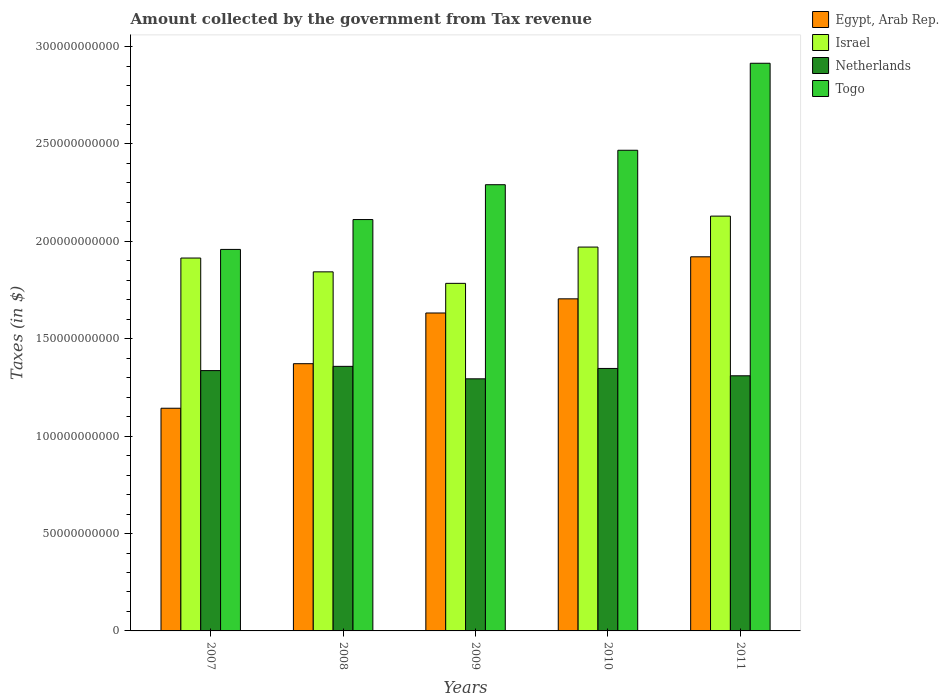How many different coloured bars are there?
Offer a terse response. 4. How many groups of bars are there?
Your answer should be compact. 5. Are the number of bars per tick equal to the number of legend labels?
Your answer should be compact. Yes. Are the number of bars on each tick of the X-axis equal?
Your answer should be very brief. Yes. What is the label of the 5th group of bars from the left?
Keep it short and to the point. 2011. In how many cases, is the number of bars for a given year not equal to the number of legend labels?
Your answer should be very brief. 0. What is the amount collected by the government from tax revenue in Israel in 2007?
Make the answer very short. 1.91e+11. Across all years, what is the maximum amount collected by the government from tax revenue in Israel?
Give a very brief answer. 2.13e+11. Across all years, what is the minimum amount collected by the government from tax revenue in Netherlands?
Offer a terse response. 1.29e+11. In which year was the amount collected by the government from tax revenue in Egypt, Arab Rep. maximum?
Your response must be concise. 2011. What is the total amount collected by the government from tax revenue in Israel in the graph?
Keep it short and to the point. 9.64e+11. What is the difference between the amount collected by the government from tax revenue in Netherlands in 2007 and that in 2009?
Keep it short and to the point. 4.22e+09. What is the difference between the amount collected by the government from tax revenue in Egypt, Arab Rep. in 2008 and the amount collected by the government from tax revenue in Netherlands in 2010?
Offer a terse response. 2.44e+09. What is the average amount collected by the government from tax revenue in Netherlands per year?
Provide a succinct answer. 1.33e+11. In the year 2007, what is the difference between the amount collected by the government from tax revenue in Egypt, Arab Rep. and amount collected by the government from tax revenue in Togo?
Your answer should be very brief. -8.15e+1. What is the ratio of the amount collected by the government from tax revenue in Netherlands in 2008 to that in 2010?
Provide a succinct answer. 1.01. Is the amount collected by the government from tax revenue in Netherlands in 2007 less than that in 2010?
Offer a very short reply. Yes. What is the difference between the highest and the second highest amount collected by the government from tax revenue in Egypt, Arab Rep.?
Your answer should be very brief. 2.16e+1. What is the difference between the highest and the lowest amount collected by the government from tax revenue in Netherlands?
Your response must be concise. 6.40e+09. In how many years, is the amount collected by the government from tax revenue in Israel greater than the average amount collected by the government from tax revenue in Israel taken over all years?
Make the answer very short. 2. Is the sum of the amount collected by the government from tax revenue in Togo in 2007 and 2010 greater than the maximum amount collected by the government from tax revenue in Netherlands across all years?
Ensure brevity in your answer.  Yes. What does the 3rd bar from the left in 2008 represents?
Make the answer very short. Netherlands. What does the 2nd bar from the right in 2009 represents?
Give a very brief answer. Netherlands. Is it the case that in every year, the sum of the amount collected by the government from tax revenue in Netherlands and amount collected by the government from tax revenue in Togo is greater than the amount collected by the government from tax revenue in Israel?
Offer a terse response. Yes. Are the values on the major ticks of Y-axis written in scientific E-notation?
Provide a succinct answer. No. Does the graph contain any zero values?
Provide a short and direct response. No. Does the graph contain grids?
Offer a terse response. No. How many legend labels are there?
Give a very brief answer. 4. How are the legend labels stacked?
Offer a very short reply. Vertical. What is the title of the graph?
Ensure brevity in your answer.  Amount collected by the government from Tax revenue. Does "Andorra" appear as one of the legend labels in the graph?
Your answer should be very brief. No. What is the label or title of the X-axis?
Give a very brief answer. Years. What is the label or title of the Y-axis?
Provide a succinct answer. Taxes (in $). What is the Taxes (in $) in Egypt, Arab Rep. in 2007?
Your answer should be very brief. 1.14e+11. What is the Taxes (in $) of Israel in 2007?
Your response must be concise. 1.91e+11. What is the Taxes (in $) in Netherlands in 2007?
Offer a very short reply. 1.34e+11. What is the Taxes (in $) of Togo in 2007?
Ensure brevity in your answer.  1.96e+11. What is the Taxes (in $) of Egypt, Arab Rep. in 2008?
Make the answer very short. 1.37e+11. What is the Taxes (in $) of Israel in 2008?
Make the answer very short. 1.84e+11. What is the Taxes (in $) of Netherlands in 2008?
Give a very brief answer. 1.36e+11. What is the Taxes (in $) of Togo in 2008?
Ensure brevity in your answer.  2.11e+11. What is the Taxes (in $) in Egypt, Arab Rep. in 2009?
Ensure brevity in your answer.  1.63e+11. What is the Taxes (in $) of Israel in 2009?
Offer a very short reply. 1.78e+11. What is the Taxes (in $) in Netherlands in 2009?
Make the answer very short. 1.29e+11. What is the Taxes (in $) in Togo in 2009?
Offer a very short reply. 2.29e+11. What is the Taxes (in $) of Egypt, Arab Rep. in 2010?
Your response must be concise. 1.70e+11. What is the Taxes (in $) in Israel in 2010?
Offer a terse response. 1.97e+11. What is the Taxes (in $) of Netherlands in 2010?
Offer a terse response. 1.35e+11. What is the Taxes (in $) in Togo in 2010?
Provide a succinct answer. 2.47e+11. What is the Taxes (in $) in Egypt, Arab Rep. in 2011?
Ensure brevity in your answer.  1.92e+11. What is the Taxes (in $) in Israel in 2011?
Offer a very short reply. 2.13e+11. What is the Taxes (in $) of Netherlands in 2011?
Ensure brevity in your answer.  1.31e+11. What is the Taxes (in $) in Togo in 2011?
Make the answer very short. 2.91e+11. Across all years, what is the maximum Taxes (in $) of Egypt, Arab Rep.?
Your answer should be very brief. 1.92e+11. Across all years, what is the maximum Taxes (in $) in Israel?
Provide a short and direct response. 2.13e+11. Across all years, what is the maximum Taxes (in $) in Netherlands?
Provide a short and direct response. 1.36e+11. Across all years, what is the maximum Taxes (in $) in Togo?
Keep it short and to the point. 2.91e+11. Across all years, what is the minimum Taxes (in $) in Egypt, Arab Rep.?
Ensure brevity in your answer.  1.14e+11. Across all years, what is the minimum Taxes (in $) of Israel?
Your answer should be compact. 1.78e+11. Across all years, what is the minimum Taxes (in $) of Netherlands?
Ensure brevity in your answer.  1.29e+11. Across all years, what is the minimum Taxes (in $) in Togo?
Your response must be concise. 1.96e+11. What is the total Taxes (in $) in Egypt, Arab Rep. in the graph?
Give a very brief answer. 7.77e+11. What is the total Taxes (in $) in Israel in the graph?
Keep it short and to the point. 9.64e+11. What is the total Taxes (in $) of Netherlands in the graph?
Ensure brevity in your answer.  6.65e+11. What is the total Taxes (in $) in Togo in the graph?
Provide a succinct answer. 1.17e+12. What is the difference between the Taxes (in $) of Egypt, Arab Rep. in 2007 and that in 2008?
Offer a very short reply. -2.29e+1. What is the difference between the Taxes (in $) of Israel in 2007 and that in 2008?
Offer a terse response. 7.09e+09. What is the difference between the Taxes (in $) of Netherlands in 2007 and that in 2008?
Offer a very short reply. -2.18e+09. What is the difference between the Taxes (in $) in Togo in 2007 and that in 2008?
Provide a short and direct response. -1.53e+1. What is the difference between the Taxes (in $) of Egypt, Arab Rep. in 2007 and that in 2009?
Ensure brevity in your answer.  -4.89e+1. What is the difference between the Taxes (in $) in Israel in 2007 and that in 2009?
Give a very brief answer. 1.30e+1. What is the difference between the Taxes (in $) of Netherlands in 2007 and that in 2009?
Provide a succinct answer. 4.22e+09. What is the difference between the Taxes (in $) of Togo in 2007 and that in 2009?
Give a very brief answer. -3.32e+1. What is the difference between the Taxes (in $) of Egypt, Arab Rep. in 2007 and that in 2010?
Your answer should be very brief. -5.62e+1. What is the difference between the Taxes (in $) of Israel in 2007 and that in 2010?
Keep it short and to the point. -5.63e+09. What is the difference between the Taxes (in $) of Netherlands in 2007 and that in 2010?
Offer a terse response. -1.10e+09. What is the difference between the Taxes (in $) of Togo in 2007 and that in 2010?
Your answer should be very brief. -5.09e+1. What is the difference between the Taxes (in $) in Egypt, Arab Rep. in 2007 and that in 2011?
Your answer should be compact. -7.77e+1. What is the difference between the Taxes (in $) in Israel in 2007 and that in 2011?
Your response must be concise. -2.15e+1. What is the difference between the Taxes (in $) in Netherlands in 2007 and that in 2011?
Offer a terse response. 2.67e+09. What is the difference between the Taxes (in $) of Togo in 2007 and that in 2011?
Offer a terse response. -9.56e+1. What is the difference between the Taxes (in $) of Egypt, Arab Rep. in 2008 and that in 2009?
Your response must be concise. -2.60e+1. What is the difference between the Taxes (in $) in Israel in 2008 and that in 2009?
Give a very brief answer. 5.90e+09. What is the difference between the Taxes (in $) in Netherlands in 2008 and that in 2009?
Make the answer very short. 6.40e+09. What is the difference between the Taxes (in $) of Togo in 2008 and that in 2009?
Your answer should be compact. -1.79e+1. What is the difference between the Taxes (in $) in Egypt, Arab Rep. in 2008 and that in 2010?
Your answer should be very brief. -3.33e+1. What is the difference between the Taxes (in $) in Israel in 2008 and that in 2010?
Your response must be concise. -1.27e+1. What is the difference between the Taxes (in $) in Netherlands in 2008 and that in 2010?
Your answer should be compact. 1.08e+09. What is the difference between the Taxes (in $) in Togo in 2008 and that in 2010?
Provide a succinct answer. -3.56e+1. What is the difference between the Taxes (in $) of Egypt, Arab Rep. in 2008 and that in 2011?
Provide a succinct answer. -5.49e+1. What is the difference between the Taxes (in $) of Israel in 2008 and that in 2011?
Your answer should be very brief. -2.86e+1. What is the difference between the Taxes (in $) of Netherlands in 2008 and that in 2011?
Provide a short and direct response. 4.85e+09. What is the difference between the Taxes (in $) of Togo in 2008 and that in 2011?
Provide a succinct answer. -8.02e+1. What is the difference between the Taxes (in $) of Egypt, Arab Rep. in 2009 and that in 2010?
Make the answer very short. -7.27e+09. What is the difference between the Taxes (in $) in Israel in 2009 and that in 2010?
Your answer should be compact. -1.86e+1. What is the difference between the Taxes (in $) of Netherlands in 2009 and that in 2010?
Offer a terse response. -5.33e+09. What is the difference between the Taxes (in $) of Togo in 2009 and that in 2010?
Keep it short and to the point. -1.77e+1. What is the difference between the Taxes (in $) in Egypt, Arab Rep. in 2009 and that in 2011?
Give a very brief answer. -2.88e+1. What is the difference between the Taxes (in $) in Israel in 2009 and that in 2011?
Give a very brief answer. -3.45e+1. What is the difference between the Taxes (in $) of Netherlands in 2009 and that in 2011?
Your response must be concise. -1.56e+09. What is the difference between the Taxes (in $) in Togo in 2009 and that in 2011?
Provide a short and direct response. -6.24e+1. What is the difference between the Taxes (in $) of Egypt, Arab Rep. in 2010 and that in 2011?
Offer a very short reply. -2.16e+1. What is the difference between the Taxes (in $) of Israel in 2010 and that in 2011?
Your answer should be compact. -1.59e+1. What is the difference between the Taxes (in $) in Netherlands in 2010 and that in 2011?
Give a very brief answer. 3.77e+09. What is the difference between the Taxes (in $) in Togo in 2010 and that in 2011?
Keep it short and to the point. -4.47e+1. What is the difference between the Taxes (in $) in Egypt, Arab Rep. in 2007 and the Taxes (in $) in Israel in 2008?
Provide a short and direct response. -7.00e+1. What is the difference between the Taxes (in $) in Egypt, Arab Rep. in 2007 and the Taxes (in $) in Netherlands in 2008?
Provide a short and direct response. -2.15e+1. What is the difference between the Taxes (in $) in Egypt, Arab Rep. in 2007 and the Taxes (in $) in Togo in 2008?
Provide a short and direct response. -9.69e+1. What is the difference between the Taxes (in $) in Israel in 2007 and the Taxes (in $) in Netherlands in 2008?
Your answer should be compact. 5.56e+1. What is the difference between the Taxes (in $) in Israel in 2007 and the Taxes (in $) in Togo in 2008?
Provide a short and direct response. -1.98e+1. What is the difference between the Taxes (in $) of Netherlands in 2007 and the Taxes (in $) of Togo in 2008?
Offer a terse response. -7.75e+1. What is the difference between the Taxes (in $) of Egypt, Arab Rep. in 2007 and the Taxes (in $) of Israel in 2009?
Your answer should be very brief. -6.41e+1. What is the difference between the Taxes (in $) of Egypt, Arab Rep. in 2007 and the Taxes (in $) of Netherlands in 2009?
Ensure brevity in your answer.  -1.51e+1. What is the difference between the Taxes (in $) of Egypt, Arab Rep. in 2007 and the Taxes (in $) of Togo in 2009?
Offer a very short reply. -1.15e+11. What is the difference between the Taxes (in $) of Israel in 2007 and the Taxes (in $) of Netherlands in 2009?
Provide a succinct answer. 6.20e+1. What is the difference between the Taxes (in $) of Israel in 2007 and the Taxes (in $) of Togo in 2009?
Provide a succinct answer. -3.77e+1. What is the difference between the Taxes (in $) in Netherlands in 2007 and the Taxes (in $) in Togo in 2009?
Offer a terse response. -9.54e+1. What is the difference between the Taxes (in $) in Egypt, Arab Rep. in 2007 and the Taxes (in $) in Israel in 2010?
Offer a terse response. -8.27e+1. What is the difference between the Taxes (in $) in Egypt, Arab Rep. in 2007 and the Taxes (in $) in Netherlands in 2010?
Provide a short and direct response. -2.04e+1. What is the difference between the Taxes (in $) of Egypt, Arab Rep. in 2007 and the Taxes (in $) of Togo in 2010?
Your answer should be compact. -1.32e+11. What is the difference between the Taxes (in $) in Israel in 2007 and the Taxes (in $) in Netherlands in 2010?
Offer a terse response. 5.67e+1. What is the difference between the Taxes (in $) in Israel in 2007 and the Taxes (in $) in Togo in 2010?
Ensure brevity in your answer.  -5.53e+1. What is the difference between the Taxes (in $) of Netherlands in 2007 and the Taxes (in $) of Togo in 2010?
Provide a succinct answer. -1.13e+11. What is the difference between the Taxes (in $) of Egypt, Arab Rep. in 2007 and the Taxes (in $) of Israel in 2011?
Ensure brevity in your answer.  -9.86e+1. What is the difference between the Taxes (in $) of Egypt, Arab Rep. in 2007 and the Taxes (in $) of Netherlands in 2011?
Make the answer very short. -1.67e+1. What is the difference between the Taxes (in $) of Egypt, Arab Rep. in 2007 and the Taxes (in $) of Togo in 2011?
Your answer should be very brief. -1.77e+11. What is the difference between the Taxes (in $) of Israel in 2007 and the Taxes (in $) of Netherlands in 2011?
Provide a succinct answer. 6.05e+1. What is the difference between the Taxes (in $) of Israel in 2007 and the Taxes (in $) of Togo in 2011?
Provide a succinct answer. -1.00e+11. What is the difference between the Taxes (in $) of Netherlands in 2007 and the Taxes (in $) of Togo in 2011?
Offer a very short reply. -1.58e+11. What is the difference between the Taxes (in $) in Egypt, Arab Rep. in 2008 and the Taxes (in $) in Israel in 2009?
Your answer should be very brief. -4.12e+1. What is the difference between the Taxes (in $) of Egypt, Arab Rep. in 2008 and the Taxes (in $) of Netherlands in 2009?
Provide a succinct answer. 7.77e+09. What is the difference between the Taxes (in $) of Egypt, Arab Rep. in 2008 and the Taxes (in $) of Togo in 2009?
Keep it short and to the point. -9.19e+1. What is the difference between the Taxes (in $) in Israel in 2008 and the Taxes (in $) in Netherlands in 2009?
Offer a very short reply. 5.49e+1. What is the difference between the Taxes (in $) of Israel in 2008 and the Taxes (in $) of Togo in 2009?
Make the answer very short. -4.47e+1. What is the difference between the Taxes (in $) of Netherlands in 2008 and the Taxes (in $) of Togo in 2009?
Make the answer very short. -9.33e+1. What is the difference between the Taxes (in $) in Egypt, Arab Rep. in 2008 and the Taxes (in $) in Israel in 2010?
Your answer should be very brief. -5.99e+1. What is the difference between the Taxes (in $) of Egypt, Arab Rep. in 2008 and the Taxes (in $) of Netherlands in 2010?
Your answer should be compact. 2.44e+09. What is the difference between the Taxes (in $) in Egypt, Arab Rep. in 2008 and the Taxes (in $) in Togo in 2010?
Provide a succinct answer. -1.10e+11. What is the difference between the Taxes (in $) in Israel in 2008 and the Taxes (in $) in Netherlands in 2010?
Your answer should be compact. 4.96e+1. What is the difference between the Taxes (in $) in Israel in 2008 and the Taxes (in $) in Togo in 2010?
Offer a very short reply. -6.24e+1. What is the difference between the Taxes (in $) in Netherlands in 2008 and the Taxes (in $) in Togo in 2010?
Your response must be concise. -1.11e+11. What is the difference between the Taxes (in $) in Egypt, Arab Rep. in 2008 and the Taxes (in $) in Israel in 2011?
Keep it short and to the point. -7.58e+1. What is the difference between the Taxes (in $) in Egypt, Arab Rep. in 2008 and the Taxes (in $) in Netherlands in 2011?
Offer a very short reply. 6.21e+09. What is the difference between the Taxes (in $) in Egypt, Arab Rep. in 2008 and the Taxes (in $) in Togo in 2011?
Your answer should be compact. -1.54e+11. What is the difference between the Taxes (in $) of Israel in 2008 and the Taxes (in $) of Netherlands in 2011?
Offer a very short reply. 5.34e+1. What is the difference between the Taxes (in $) of Israel in 2008 and the Taxes (in $) of Togo in 2011?
Provide a short and direct response. -1.07e+11. What is the difference between the Taxes (in $) in Netherlands in 2008 and the Taxes (in $) in Togo in 2011?
Keep it short and to the point. -1.56e+11. What is the difference between the Taxes (in $) in Egypt, Arab Rep. in 2009 and the Taxes (in $) in Israel in 2010?
Offer a terse response. -3.38e+1. What is the difference between the Taxes (in $) in Egypt, Arab Rep. in 2009 and the Taxes (in $) in Netherlands in 2010?
Ensure brevity in your answer.  2.85e+1. What is the difference between the Taxes (in $) in Egypt, Arab Rep. in 2009 and the Taxes (in $) in Togo in 2010?
Offer a very short reply. -8.36e+1. What is the difference between the Taxes (in $) in Israel in 2009 and the Taxes (in $) in Netherlands in 2010?
Ensure brevity in your answer.  4.37e+1. What is the difference between the Taxes (in $) in Israel in 2009 and the Taxes (in $) in Togo in 2010?
Your answer should be compact. -6.83e+1. What is the difference between the Taxes (in $) of Netherlands in 2009 and the Taxes (in $) of Togo in 2010?
Offer a terse response. -1.17e+11. What is the difference between the Taxes (in $) in Egypt, Arab Rep. in 2009 and the Taxes (in $) in Israel in 2011?
Give a very brief answer. -4.97e+1. What is the difference between the Taxes (in $) in Egypt, Arab Rep. in 2009 and the Taxes (in $) in Netherlands in 2011?
Keep it short and to the point. 3.22e+1. What is the difference between the Taxes (in $) of Egypt, Arab Rep. in 2009 and the Taxes (in $) of Togo in 2011?
Ensure brevity in your answer.  -1.28e+11. What is the difference between the Taxes (in $) of Israel in 2009 and the Taxes (in $) of Netherlands in 2011?
Your response must be concise. 4.75e+1. What is the difference between the Taxes (in $) of Israel in 2009 and the Taxes (in $) of Togo in 2011?
Make the answer very short. -1.13e+11. What is the difference between the Taxes (in $) of Netherlands in 2009 and the Taxes (in $) of Togo in 2011?
Provide a short and direct response. -1.62e+11. What is the difference between the Taxes (in $) in Egypt, Arab Rep. in 2010 and the Taxes (in $) in Israel in 2011?
Provide a succinct answer. -4.25e+1. What is the difference between the Taxes (in $) in Egypt, Arab Rep. in 2010 and the Taxes (in $) in Netherlands in 2011?
Offer a very short reply. 3.95e+1. What is the difference between the Taxes (in $) in Egypt, Arab Rep. in 2010 and the Taxes (in $) in Togo in 2011?
Give a very brief answer. -1.21e+11. What is the difference between the Taxes (in $) of Israel in 2010 and the Taxes (in $) of Netherlands in 2011?
Your answer should be compact. 6.61e+1. What is the difference between the Taxes (in $) in Israel in 2010 and the Taxes (in $) in Togo in 2011?
Your answer should be compact. -9.44e+1. What is the difference between the Taxes (in $) of Netherlands in 2010 and the Taxes (in $) of Togo in 2011?
Your answer should be compact. -1.57e+11. What is the average Taxes (in $) in Egypt, Arab Rep. per year?
Your answer should be compact. 1.55e+11. What is the average Taxes (in $) of Israel per year?
Keep it short and to the point. 1.93e+11. What is the average Taxes (in $) in Netherlands per year?
Keep it short and to the point. 1.33e+11. What is the average Taxes (in $) in Togo per year?
Keep it short and to the point. 2.35e+11. In the year 2007, what is the difference between the Taxes (in $) in Egypt, Arab Rep. and Taxes (in $) in Israel?
Provide a short and direct response. -7.71e+1. In the year 2007, what is the difference between the Taxes (in $) in Egypt, Arab Rep. and Taxes (in $) in Netherlands?
Make the answer very short. -1.93e+1. In the year 2007, what is the difference between the Taxes (in $) of Egypt, Arab Rep. and Taxes (in $) of Togo?
Provide a succinct answer. -8.15e+1. In the year 2007, what is the difference between the Taxes (in $) of Israel and Taxes (in $) of Netherlands?
Offer a very short reply. 5.78e+1. In the year 2007, what is the difference between the Taxes (in $) in Israel and Taxes (in $) in Togo?
Give a very brief answer. -4.43e+09. In the year 2007, what is the difference between the Taxes (in $) of Netherlands and Taxes (in $) of Togo?
Give a very brief answer. -6.22e+1. In the year 2008, what is the difference between the Taxes (in $) in Egypt, Arab Rep. and Taxes (in $) in Israel?
Offer a terse response. -4.71e+1. In the year 2008, what is the difference between the Taxes (in $) in Egypt, Arab Rep. and Taxes (in $) in Netherlands?
Offer a very short reply. 1.36e+09. In the year 2008, what is the difference between the Taxes (in $) in Egypt, Arab Rep. and Taxes (in $) in Togo?
Ensure brevity in your answer.  -7.40e+1. In the year 2008, what is the difference between the Taxes (in $) in Israel and Taxes (in $) in Netherlands?
Your response must be concise. 4.85e+1. In the year 2008, what is the difference between the Taxes (in $) in Israel and Taxes (in $) in Togo?
Offer a terse response. -2.69e+1. In the year 2008, what is the difference between the Taxes (in $) of Netherlands and Taxes (in $) of Togo?
Offer a terse response. -7.54e+1. In the year 2009, what is the difference between the Taxes (in $) in Egypt, Arab Rep. and Taxes (in $) in Israel?
Your response must be concise. -1.52e+1. In the year 2009, what is the difference between the Taxes (in $) in Egypt, Arab Rep. and Taxes (in $) in Netherlands?
Your answer should be very brief. 3.38e+1. In the year 2009, what is the difference between the Taxes (in $) of Egypt, Arab Rep. and Taxes (in $) of Togo?
Offer a terse response. -6.59e+1. In the year 2009, what is the difference between the Taxes (in $) of Israel and Taxes (in $) of Netherlands?
Your response must be concise. 4.90e+1. In the year 2009, what is the difference between the Taxes (in $) of Israel and Taxes (in $) of Togo?
Provide a short and direct response. -5.06e+1. In the year 2009, what is the difference between the Taxes (in $) of Netherlands and Taxes (in $) of Togo?
Offer a terse response. -9.97e+1. In the year 2010, what is the difference between the Taxes (in $) in Egypt, Arab Rep. and Taxes (in $) in Israel?
Ensure brevity in your answer.  -2.66e+1. In the year 2010, what is the difference between the Taxes (in $) of Egypt, Arab Rep. and Taxes (in $) of Netherlands?
Your answer should be compact. 3.57e+1. In the year 2010, what is the difference between the Taxes (in $) of Egypt, Arab Rep. and Taxes (in $) of Togo?
Ensure brevity in your answer.  -7.63e+1. In the year 2010, what is the difference between the Taxes (in $) of Israel and Taxes (in $) of Netherlands?
Your response must be concise. 6.23e+1. In the year 2010, what is the difference between the Taxes (in $) of Israel and Taxes (in $) of Togo?
Provide a succinct answer. -4.97e+1. In the year 2010, what is the difference between the Taxes (in $) of Netherlands and Taxes (in $) of Togo?
Your response must be concise. -1.12e+11. In the year 2011, what is the difference between the Taxes (in $) of Egypt, Arab Rep. and Taxes (in $) of Israel?
Your answer should be very brief. -2.09e+1. In the year 2011, what is the difference between the Taxes (in $) in Egypt, Arab Rep. and Taxes (in $) in Netherlands?
Keep it short and to the point. 6.11e+1. In the year 2011, what is the difference between the Taxes (in $) in Egypt, Arab Rep. and Taxes (in $) in Togo?
Ensure brevity in your answer.  -9.94e+1. In the year 2011, what is the difference between the Taxes (in $) in Israel and Taxes (in $) in Netherlands?
Give a very brief answer. 8.20e+1. In the year 2011, what is the difference between the Taxes (in $) of Israel and Taxes (in $) of Togo?
Offer a very short reply. -7.85e+1. In the year 2011, what is the difference between the Taxes (in $) of Netherlands and Taxes (in $) of Togo?
Your answer should be very brief. -1.60e+11. What is the ratio of the Taxes (in $) in Netherlands in 2007 to that in 2008?
Your response must be concise. 0.98. What is the ratio of the Taxes (in $) of Togo in 2007 to that in 2008?
Keep it short and to the point. 0.93. What is the ratio of the Taxes (in $) of Egypt, Arab Rep. in 2007 to that in 2009?
Give a very brief answer. 0.7. What is the ratio of the Taxes (in $) in Israel in 2007 to that in 2009?
Offer a very short reply. 1.07. What is the ratio of the Taxes (in $) of Netherlands in 2007 to that in 2009?
Ensure brevity in your answer.  1.03. What is the ratio of the Taxes (in $) in Togo in 2007 to that in 2009?
Give a very brief answer. 0.85. What is the ratio of the Taxes (in $) in Egypt, Arab Rep. in 2007 to that in 2010?
Keep it short and to the point. 0.67. What is the ratio of the Taxes (in $) of Israel in 2007 to that in 2010?
Ensure brevity in your answer.  0.97. What is the ratio of the Taxes (in $) of Togo in 2007 to that in 2010?
Offer a terse response. 0.79. What is the ratio of the Taxes (in $) of Egypt, Arab Rep. in 2007 to that in 2011?
Offer a terse response. 0.6. What is the ratio of the Taxes (in $) of Israel in 2007 to that in 2011?
Offer a very short reply. 0.9. What is the ratio of the Taxes (in $) in Netherlands in 2007 to that in 2011?
Make the answer very short. 1.02. What is the ratio of the Taxes (in $) of Togo in 2007 to that in 2011?
Ensure brevity in your answer.  0.67. What is the ratio of the Taxes (in $) of Egypt, Arab Rep. in 2008 to that in 2009?
Give a very brief answer. 0.84. What is the ratio of the Taxes (in $) in Israel in 2008 to that in 2009?
Give a very brief answer. 1.03. What is the ratio of the Taxes (in $) of Netherlands in 2008 to that in 2009?
Ensure brevity in your answer.  1.05. What is the ratio of the Taxes (in $) in Togo in 2008 to that in 2009?
Provide a short and direct response. 0.92. What is the ratio of the Taxes (in $) in Egypt, Arab Rep. in 2008 to that in 2010?
Provide a short and direct response. 0.8. What is the ratio of the Taxes (in $) in Israel in 2008 to that in 2010?
Your answer should be compact. 0.94. What is the ratio of the Taxes (in $) of Togo in 2008 to that in 2010?
Your answer should be compact. 0.86. What is the ratio of the Taxes (in $) of Egypt, Arab Rep. in 2008 to that in 2011?
Your answer should be compact. 0.71. What is the ratio of the Taxes (in $) in Israel in 2008 to that in 2011?
Keep it short and to the point. 0.87. What is the ratio of the Taxes (in $) of Netherlands in 2008 to that in 2011?
Offer a very short reply. 1.04. What is the ratio of the Taxes (in $) in Togo in 2008 to that in 2011?
Your answer should be compact. 0.72. What is the ratio of the Taxes (in $) of Egypt, Arab Rep. in 2009 to that in 2010?
Provide a succinct answer. 0.96. What is the ratio of the Taxes (in $) of Israel in 2009 to that in 2010?
Your answer should be very brief. 0.91. What is the ratio of the Taxes (in $) of Netherlands in 2009 to that in 2010?
Your answer should be very brief. 0.96. What is the ratio of the Taxes (in $) in Togo in 2009 to that in 2010?
Your answer should be compact. 0.93. What is the ratio of the Taxes (in $) of Egypt, Arab Rep. in 2009 to that in 2011?
Make the answer very short. 0.85. What is the ratio of the Taxes (in $) in Israel in 2009 to that in 2011?
Offer a terse response. 0.84. What is the ratio of the Taxes (in $) in Netherlands in 2009 to that in 2011?
Provide a short and direct response. 0.99. What is the ratio of the Taxes (in $) in Togo in 2009 to that in 2011?
Your response must be concise. 0.79. What is the ratio of the Taxes (in $) in Egypt, Arab Rep. in 2010 to that in 2011?
Provide a succinct answer. 0.89. What is the ratio of the Taxes (in $) in Israel in 2010 to that in 2011?
Offer a terse response. 0.93. What is the ratio of the Taxes (in $) in Netherlands in 2010 to that in 2011?
Your response must be concise. 1.03. What is the ratio of the Taxes (in $) in Togo in 2010 to that in 2011?
Give a very brief answer. 0.85. What is the difference between the highest and the second highest Taxes (in $) in Egypt, Arab Rep.?
Provide a succinct answer. 2.16e+1. What is the difference between the highest and the second highest Taxes (in $) of Israel?
Your answer should be very brief. 1.59e+1. What is the difference between the highest and the second highest Taxes (in $) of Netherlands?
Your answer should be compact. 1.08e+09. What is the difference between the highest and the second highest Taxes (in $) of Togo?
Your answer should be very brief. 4.47e+1. What is the difference between the highest and the lowest Taxes (in $) in Egypt, Arab Rep.?
Provide a short and direct response. 7.77e+1. What is the difference between the highest and the lowest Taxes (in $) in Israel?
Give a very brief answer. 3.45e+1. What is the difference between the highest and the lowest Taxes (in $) of Netherlands?
Your answer should be very brief. 6.40e+09. What is the difference between the highest and the lowest Taxes (in $) of Togo?
Your answer should be compact. 9.56e+1. 